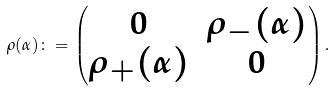<formula> <loc_0><loc_0><loc_500><loc_500>\rho ( \alpha ) \colon = \begin{pmatrix} 0 & \rho _ { - } ( \alpha ) \\ \rho _ { + } ( \alpha ) & 0 \end{pmatrix} .</formula> 